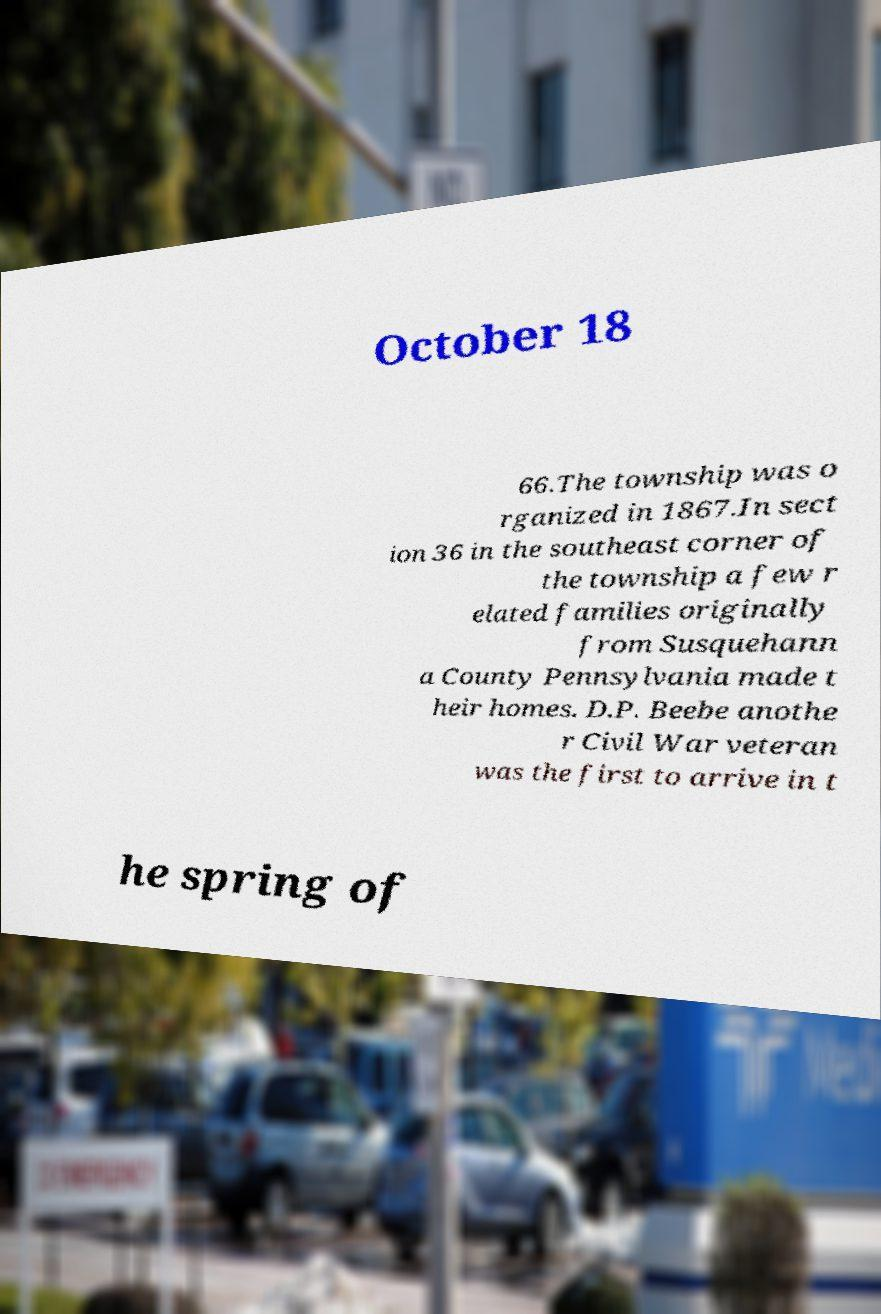What messages or text are displayed in this image? I need them in a readable, typed format. October 18 66.The township was o rganized in 1867.In sect ion 36 in the southeast corner of the township a few r elated families originally from Susquehann a County Pennsylvania made t heir homes. D.P. Beebe anothe r Civil War veteran was the first to arrive in t he spring of 